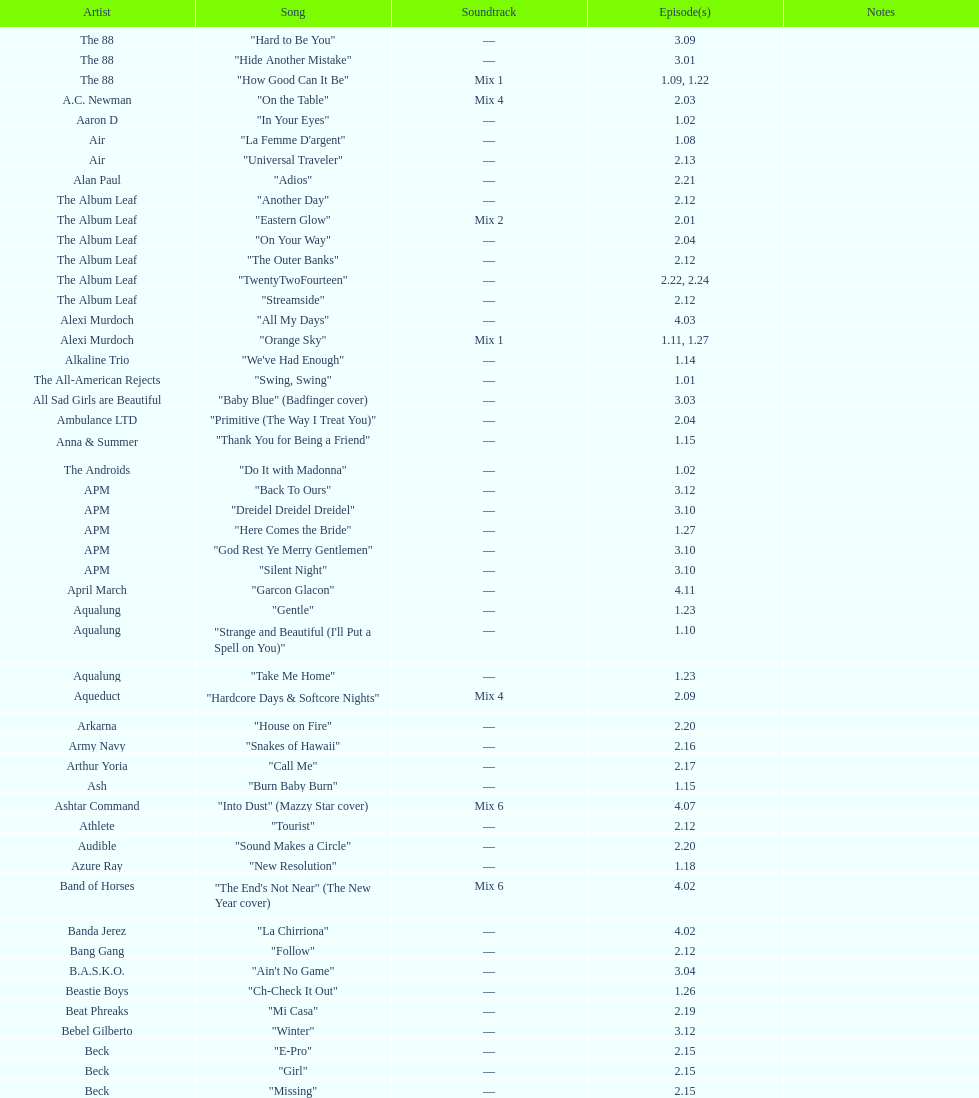What is the count of continuous songs by the album leaf? 6. 